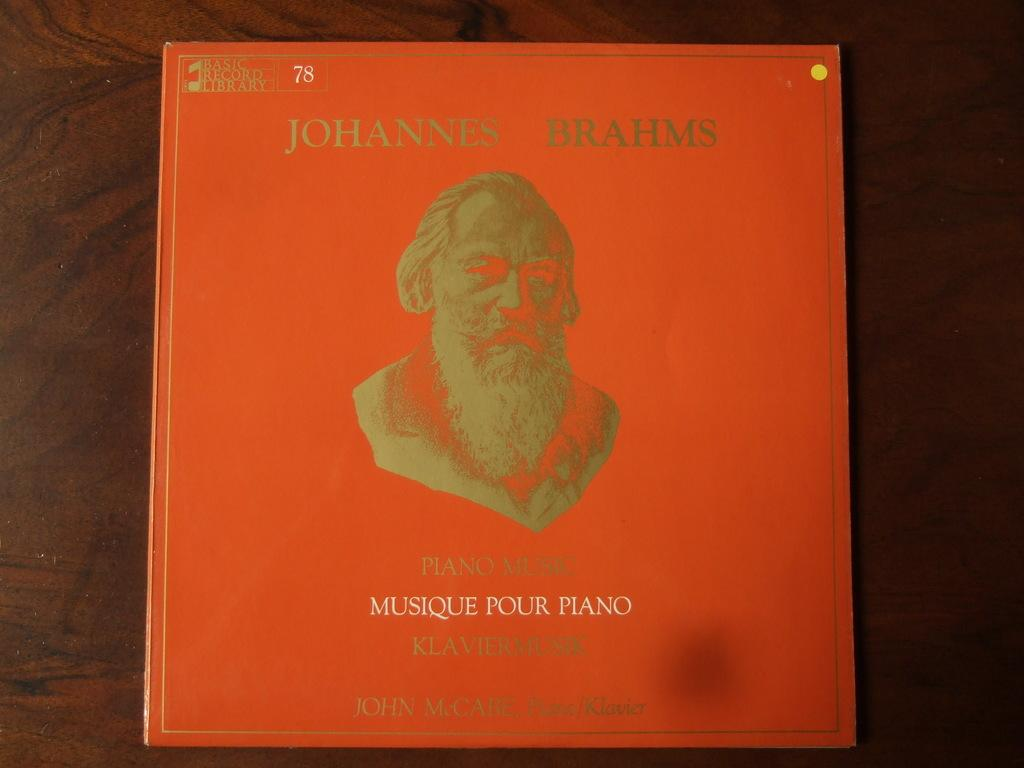What is the main subject in the middle of the image? There is a book in the middle of the image. What can be found inside the book? The book contains text. Can you describe the content of the book? There is a man in the book. Where is the son playing in the park in the image? There is no son playing in the park in the image; it only features a book with text and a man. 